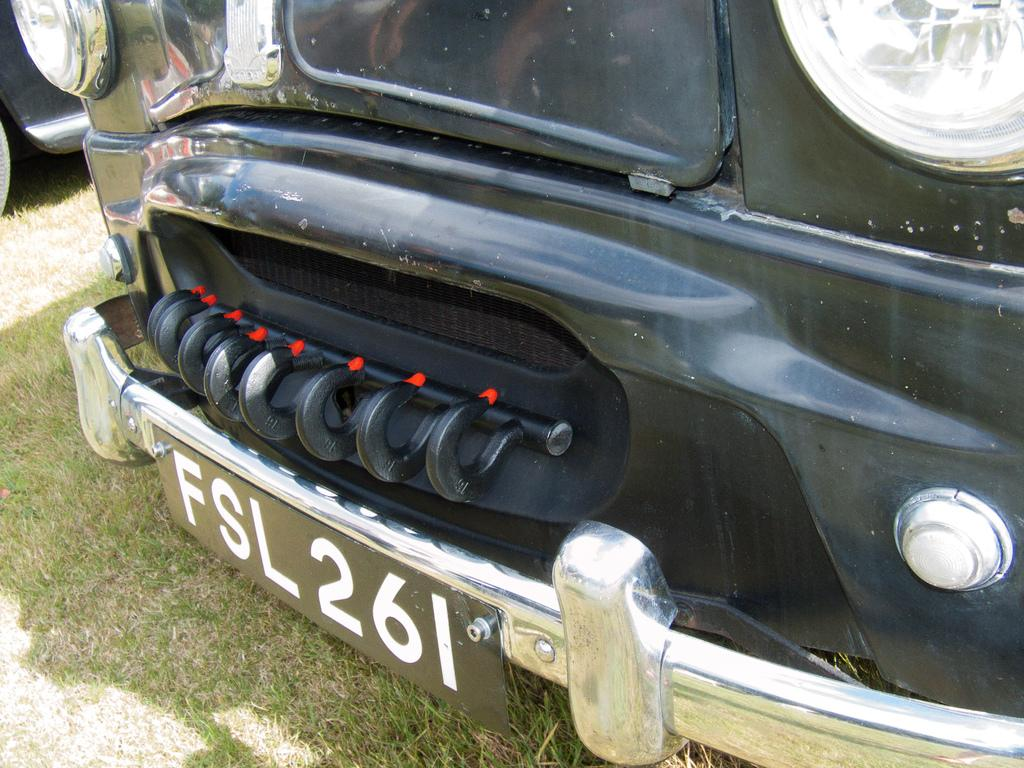What is present in the image? There are vehicles in the image. Where are the vehicles located? The vehicles are on the grass. Can you provide any specific detail about one of the vehicles? The number plate of one vehicle is visible in the image. What type of knowledge can be gained from observing the goose in the image? There is no goose present in the image, so no knowledge can be gained from observing it. 